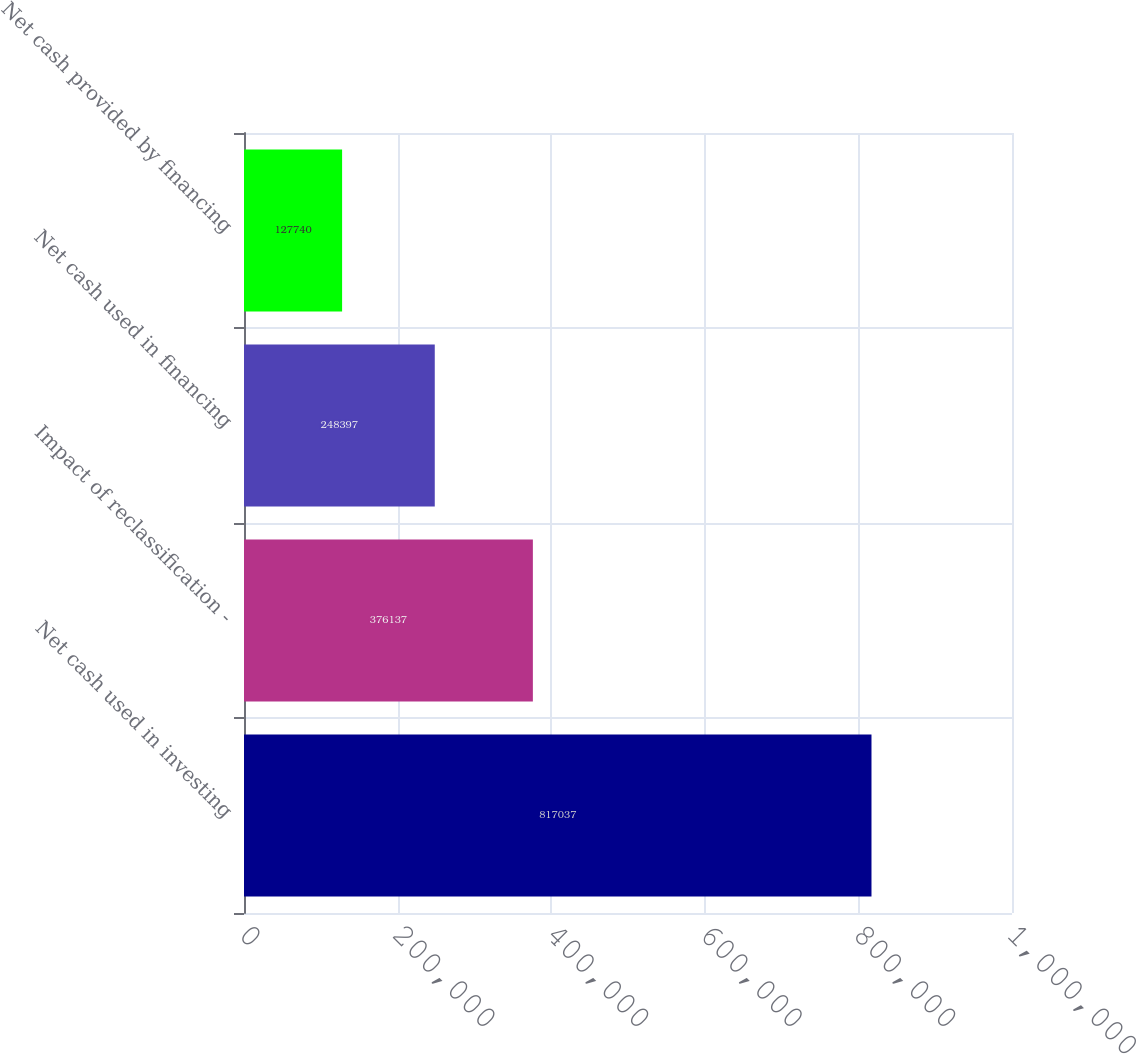Convert chart. <chart><loc_0><loc_0><loc_500><loc_500><bar_chart><fcel>Net cash used in investing<fcel>Impact of reclassification -<fcel>Net cash used in financing<fcel>Net cash provided by financing<nl><fcel>817037<fcel>376137<fcel>248397<fcel>127740<nl></chart> 